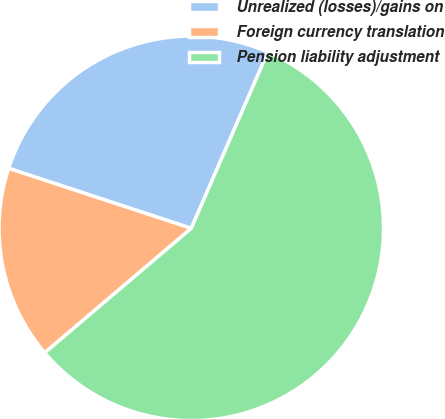Convert chart to OTSL. <chart><loc_0><loc_0><loc_500><loc_500><pie_chart><fcel>Unrealized (losses)/gains on<fcel>Foreign currency translation<fcel>Pension liability adjustment<nl><fcel>26.47%<fcel>16.26%<fcel>57.27%<nl></chart> 